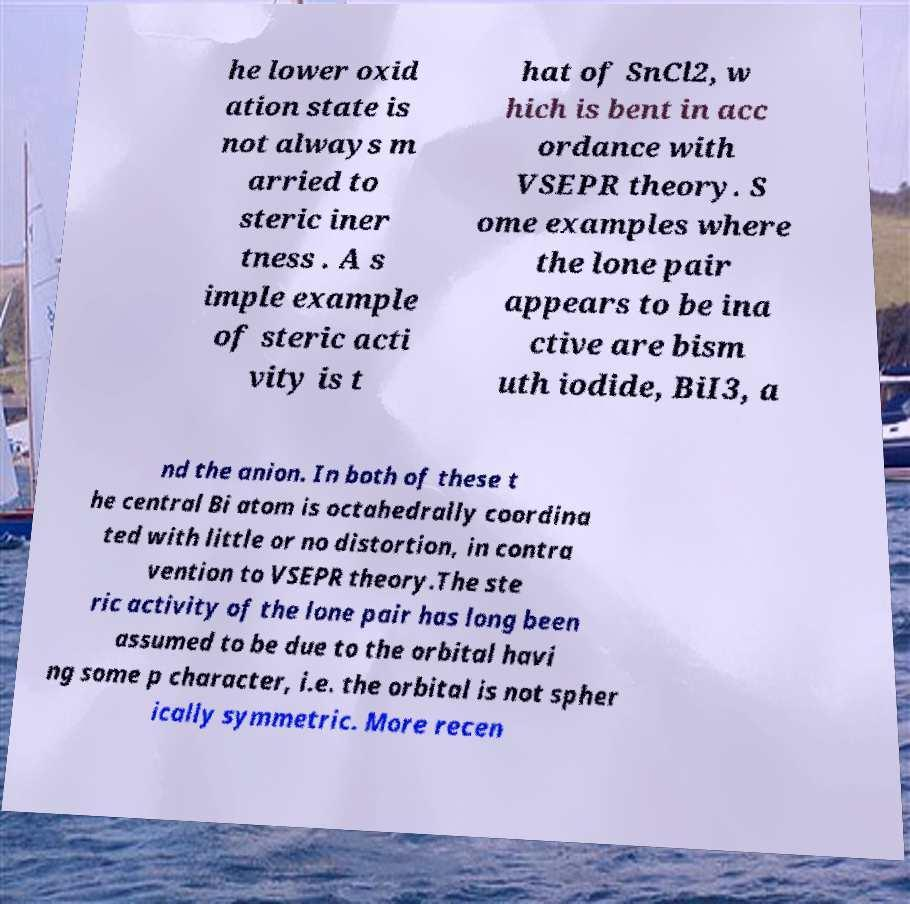Please identify and transcribe the text found in this image. he lower oxid ation state is not always m arried to steric iner tness . A s imple example of steric acti vity is t hat of SnCl2, w hich is bent in acc ordance with VSEPR theory. S ome examples where the lone pair appears to be ina ctive are bism uth iodide, BiI3, a nd the anion. In both of these t he central Bi atom is octahedrally coordina ted with little or no distortion, in contra vention to VSEPR theory.The ste ric activity of the lone pair has long been assumed to be due to the orbital havi ng some p character, i.e. the orbital is not spher ically symmetric. More recen 